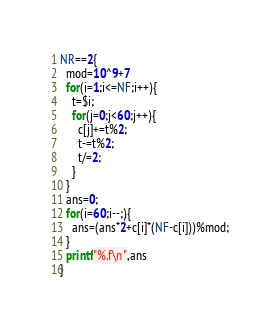<code> <loc_0><loc_0><loc_500><loc_500><_Awk_>NR==2{
  mod=10^9+7
  for(i=1;i<=NF;i++){
    t=$i;
    for(j=0;j<60;j++){
      c[j]+=t%2;
      t-=t%2;
      t/=2;
    }
  }
  ans=0;
  for(i=60;i--;){
    ans=(ans*2+c[i]*(NF-c[i]))%mod;
  }
  printf"%.f\n",ans
}</code> 